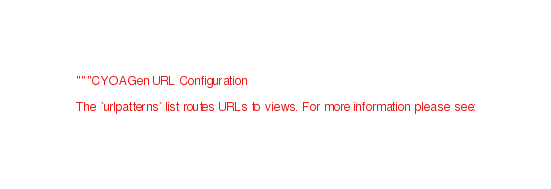<code> <loc_0><loc_0><loc_500><loc_500><_Python_>"""CYOAGen URL Configuration

The `urlpatterns` list routes URLs to views. For more information please see:</code> 